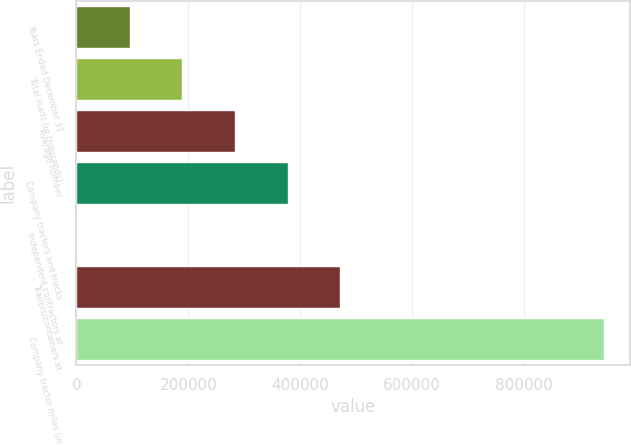Convert chart to OTSL. <chart><loc_0><loc_0><loc_500><loc_500><bar_chart><fcel>Years Ended December 31<fcel>Total loads (in thousands)<fcel>Average number<fcel>Company tractors and trucks<fcel>Independent contractors at<fcel>Trailers/containers at<fcel>Company tractor miles (in<nl><fcel>95477.3<fcel>189654<fcel>283830<fcel>378006<fcel>1301<fcel>472182<fcel>943064<nl></chart> 